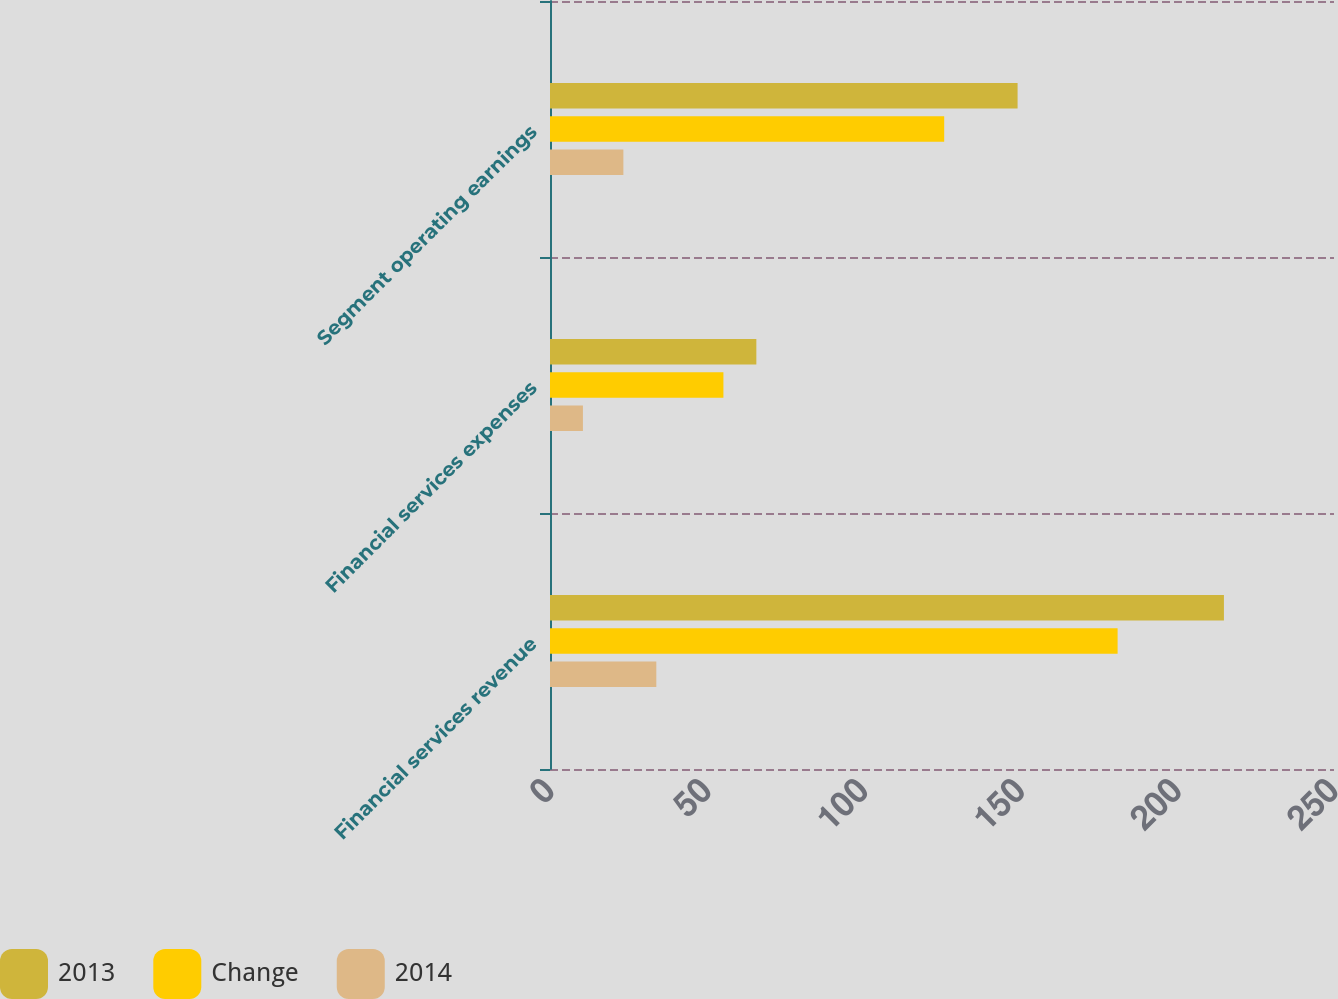<chart> <loc_0><loc_0><loc_500><loc_500><stacked_bar_chart><ecel><fcel>Financial services revenue<fcel>Financial services expenses<fcel>Segment operating earnings<nl><fcel>2013<fcel>214.9<fcel>65.8<fcel>149.1<nl><fcel>Change<fcel>181<fcel>55.3<fcel>125.7<nl><fcel>2014<fcel>33.9<fcel>10.5<fcel>23.4<nl></chart> 